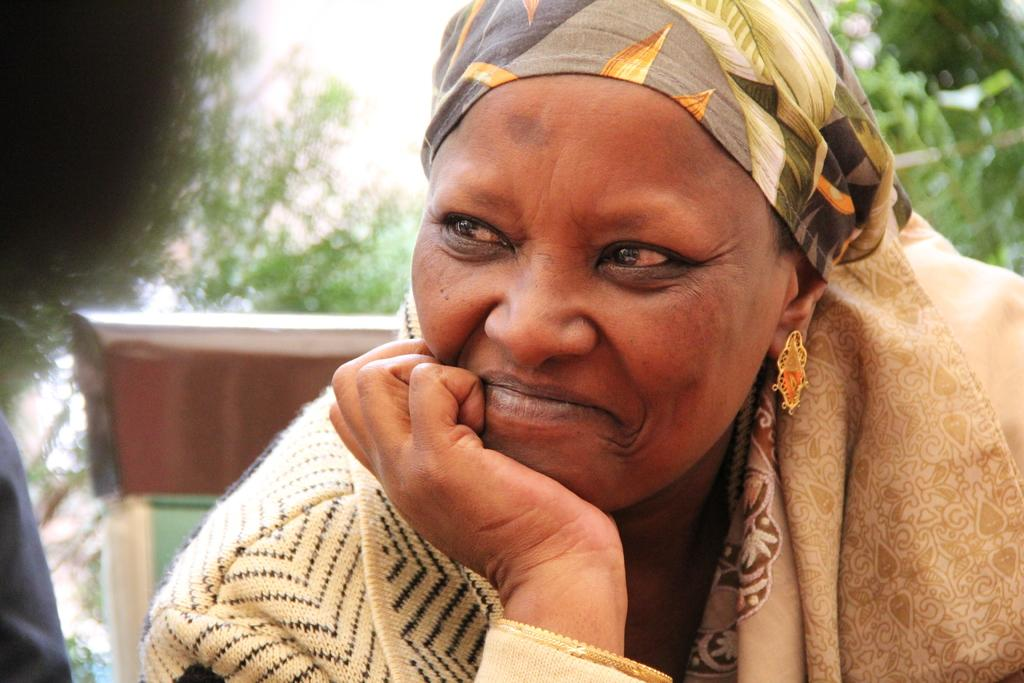What is the woman in the chair doing in the image? The woman is seated in the chair and has a smile on her face. What can be seen on the woman's head? The woman has a cloth on her head. Is there anyone else in the image? Yes, there is another woman seated nearby. What can be seen in the background of the image? Trees are visible in the image. How many snails can be seen climbing the woman's chair in the image? There are no snails visible in the image, so it is not possible to determine how many might be climbing the chair. 